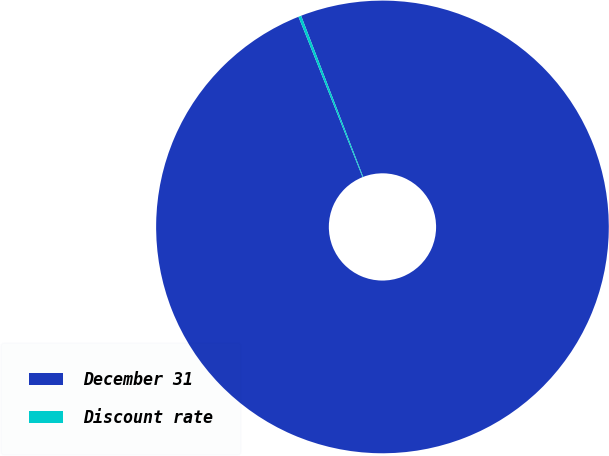Convert chart to OTSL. <chart><loc_0><loc_0><loc_500><loc_500><pie_chart><fcel>December 31<fcel>Discount rate<nl><fcel>99.8%<fcel>0.2%<nl></chart> 